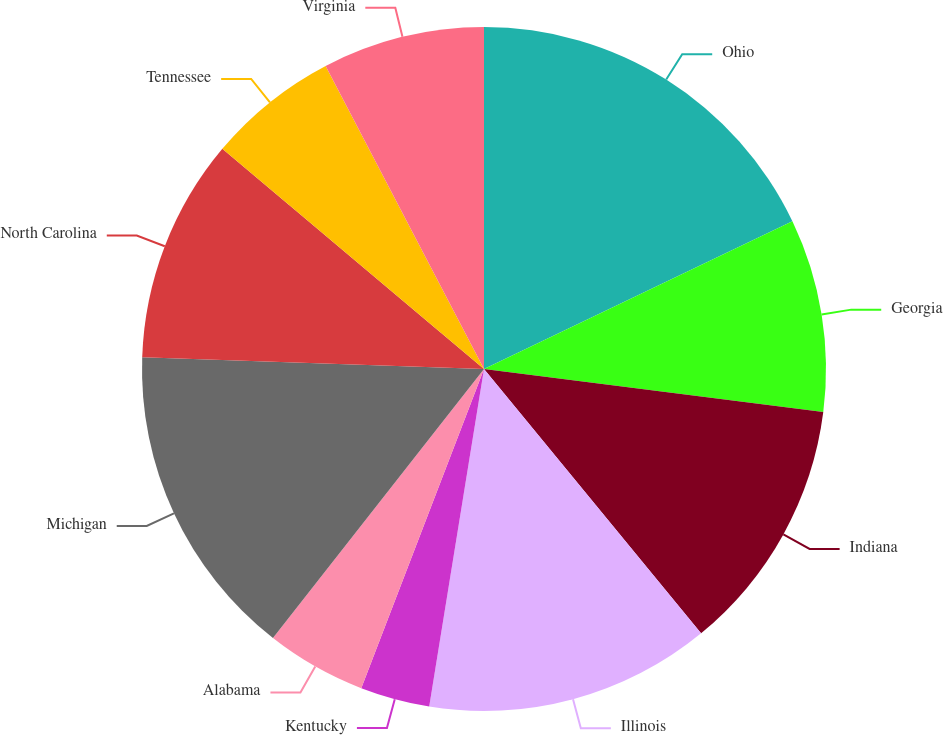Convert chart to OTSL. <chart><loc_0><loc_0><loc_500><loc_500><pie_chart><fcel>Ohio<fcel>Georgia<fcel>Indiana<fcel>Illinois<fcel>Kentucky<fcel>Alabama<fcel>Michigan<fcel>North Carolina<fcel>Tennessee<fcel>Virginia<nl><fcel>17.88%<fcel>9.12%<fcel>12.04%<fcel>13.5%<fcel>3.28%<fcel>4.74%<fcel>14.96%<fcel>10.58%<fcel>6.2%<fcel>7.66%<nl></chart> 